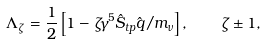Convert formula to latex. <formula><loc_0><loc_0><loc_500><loc_500>\Lambda _ { \zeta } = \frac { 1 } { 2 } \left [ 1 - \zeta \gamma ^ { 5 } \hat { S } _ { t p } \hat { q } / m _ { \nu } \right ] , \quad \zeta \pm 1 ,</formula> 